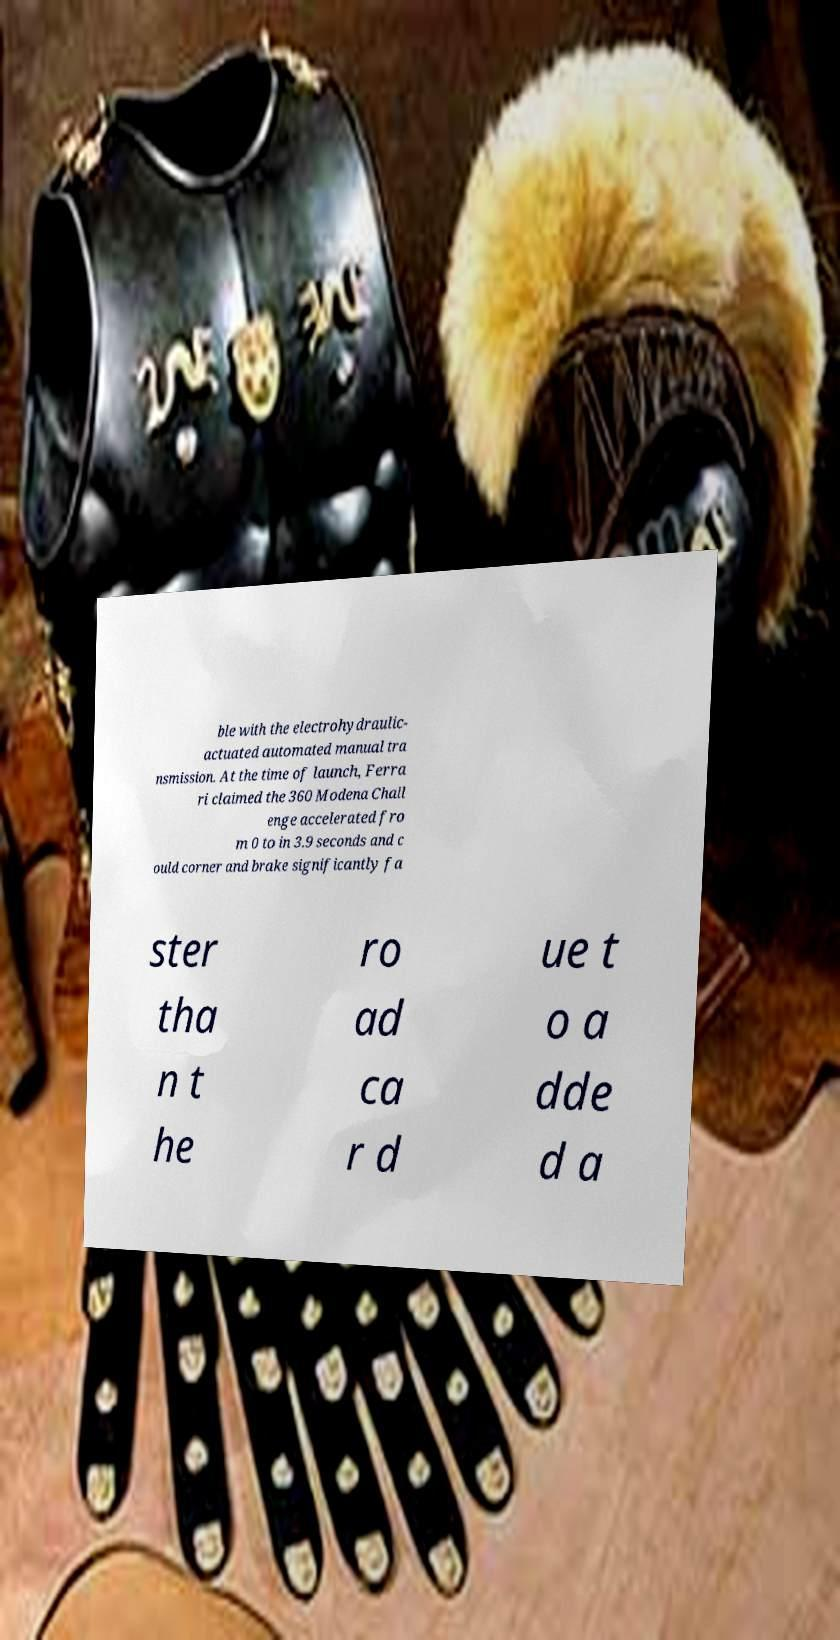Can you accurately transcribe the text from the provided image for me? ble with the electrohydraulic- actuated automated manual tra nsmission. At the time of launch, Ferra ri claimed the 360 Modena Chall enge accelerated fro m 0 to in 3.9 seconds and c ould corner and brake significantly fa ster tha n t he ro ad ca r d ue t o a dde d a 